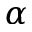<formula> <loc_0><loc_0><loc_500><loc_500>\alpha</formula> 